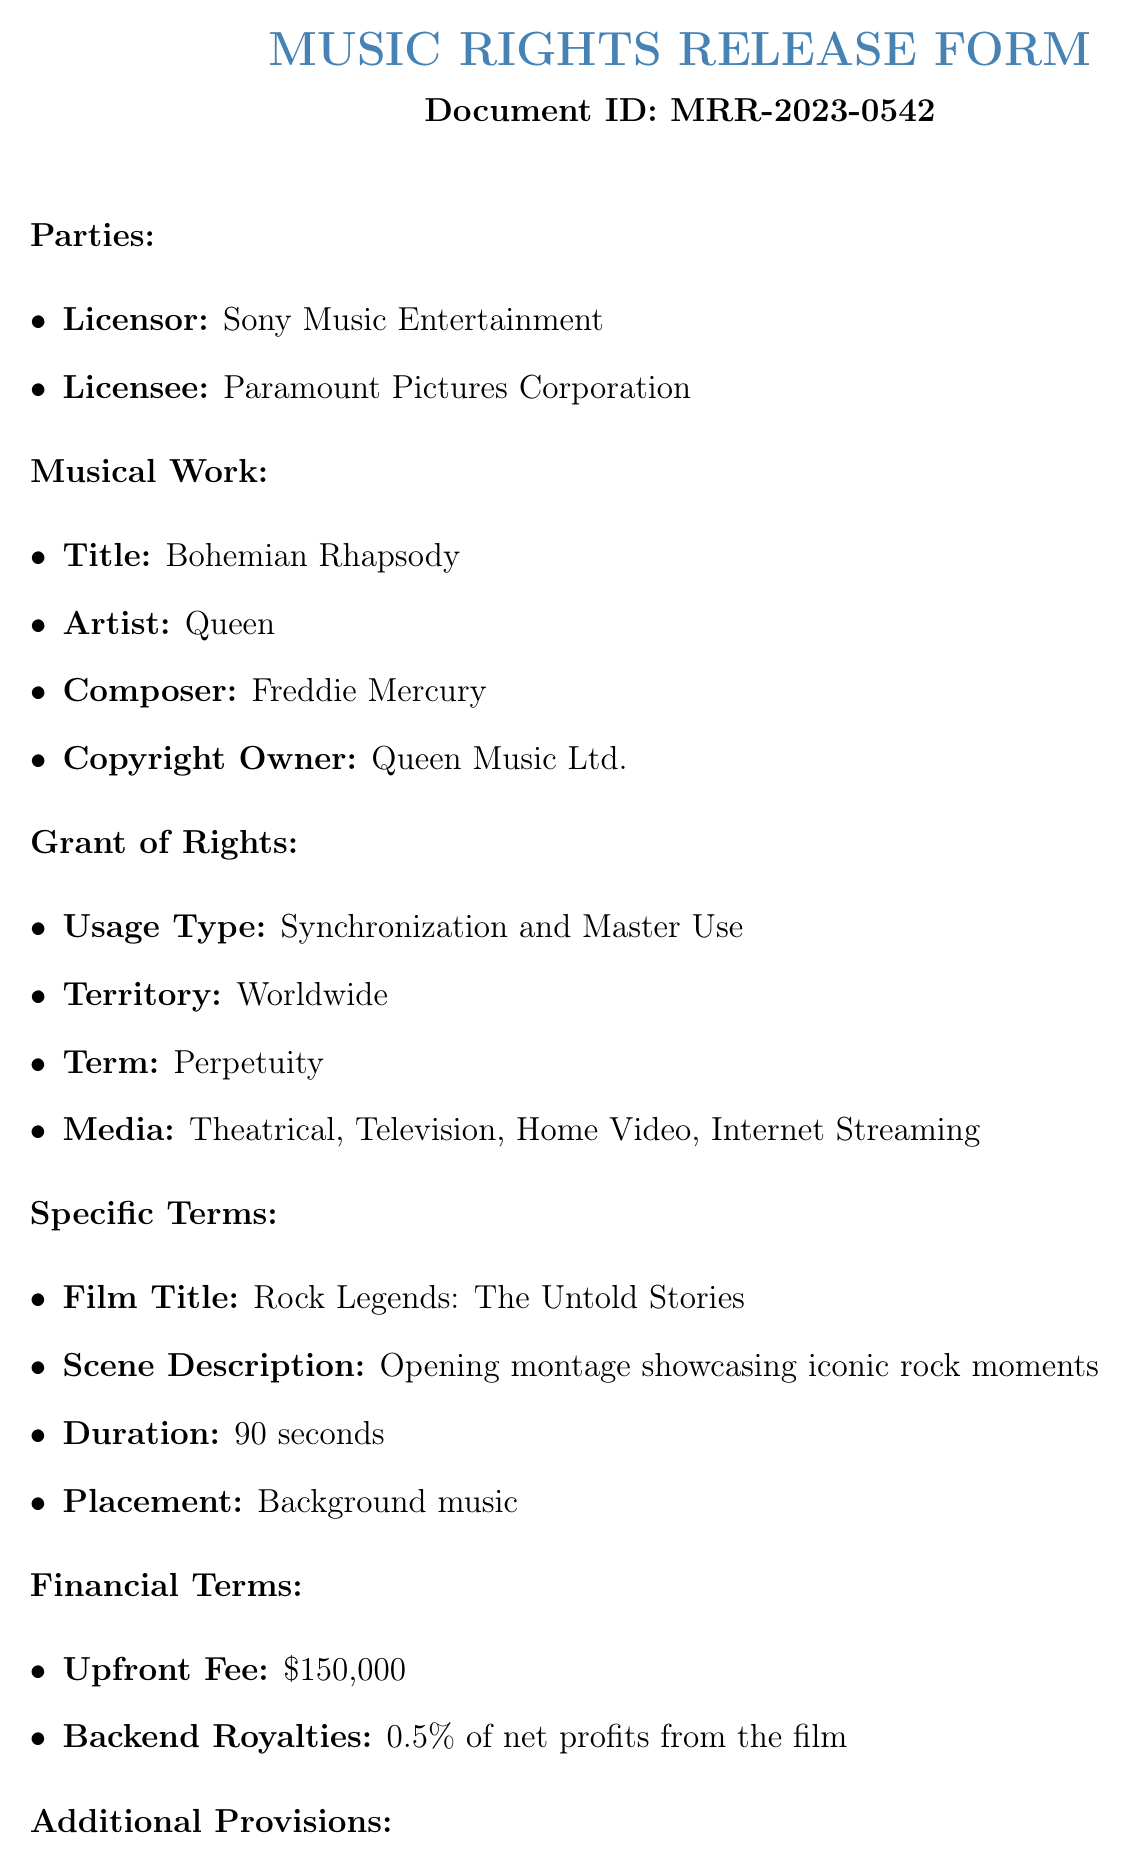What is the title of the musical work? The title of the musical work is clearly stated under the "Musical Work" section.
Answer: Bohemian Rhapsody Who is the copyright owner of the musical work? The copyright owner is listed under the "Musical Work" section of the document.
Answer: Queen Music Ltd What is the upfront fee for the usage rights? The upfront fee is specified in the "Financial Terms" section of the document.
Answer: $150,000 What is the duration of music usage in the film? The duration is included in the "Specific Terms" section concerning the integration of the musical work.
Answer: 90 seconds What rights does the Licensor retain over the scene? The rights retained by the Licensor can be found in the "Additional Provisions" section of the document.
Answer: Approval Rights For what media can the music be used? The allowed media types are specified in the "Grant of Rights" section.
Answer: Theatrical, Television, Home Video, Internet Streaming What is the percentage of backend royalties? The percentage is mentioned in the "Financial Terms" section of the document for royalties.
Answer: 0.5% What is the name of the film in which the music will be used? The name of the film is detailed under the "Specific Terms" heading.
Answer: Rock Legends: The Untold Stories Who signed as VP of Licensing for Sony Music Entertainment? The signatory is listed at the end of the document in the signature section.
Answer: John Smith 